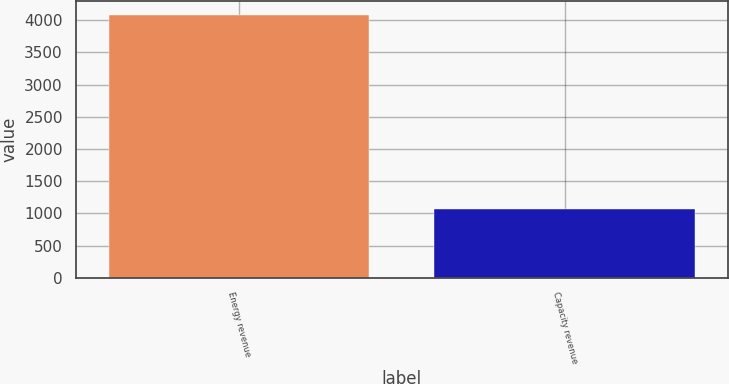Convert chart. <chart><loc_0><loc_0><loc_500><loc_500><bar_chart><fcel>Energy revenue<fcel>Capacity revenue<nl><fcel>4087<fcel>1070<nl></chart> 